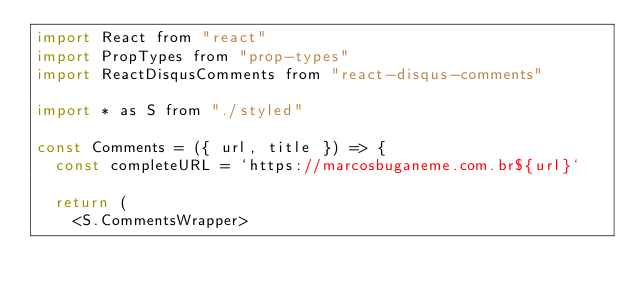Convert code to text. <code><loc_0><loc_0><loc_500><loc_500><_JavaScript_>import React from "react"
import PropTypes from "prop-types"
import ReactDisqusComments from "react-disqus-comments"

import * as S from "./styled"

const Comments = ({ url, title }) => {
  const completeURL = `https://marcosbuganeme.com.br${url}`

  return (
    <S.CommentsWrapper></code> 